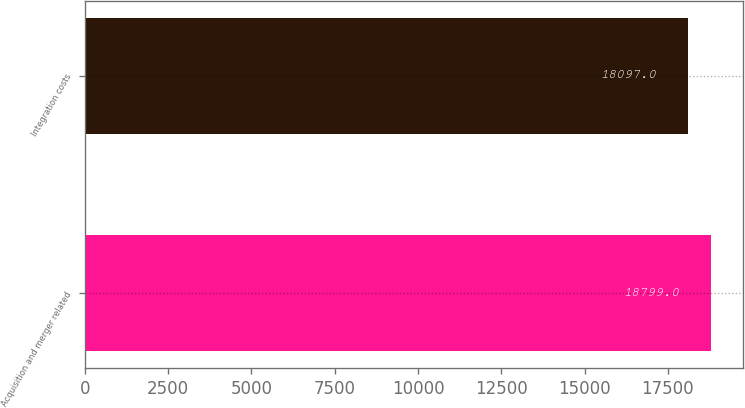Convert chart. <chart><loc_0><loc_0><loc_500><loc_500><bar_chart><fcel>Acquisition and merger related<fcel>Integration costs<nl><fcel>18799<fcel>18097<nl></chart> 